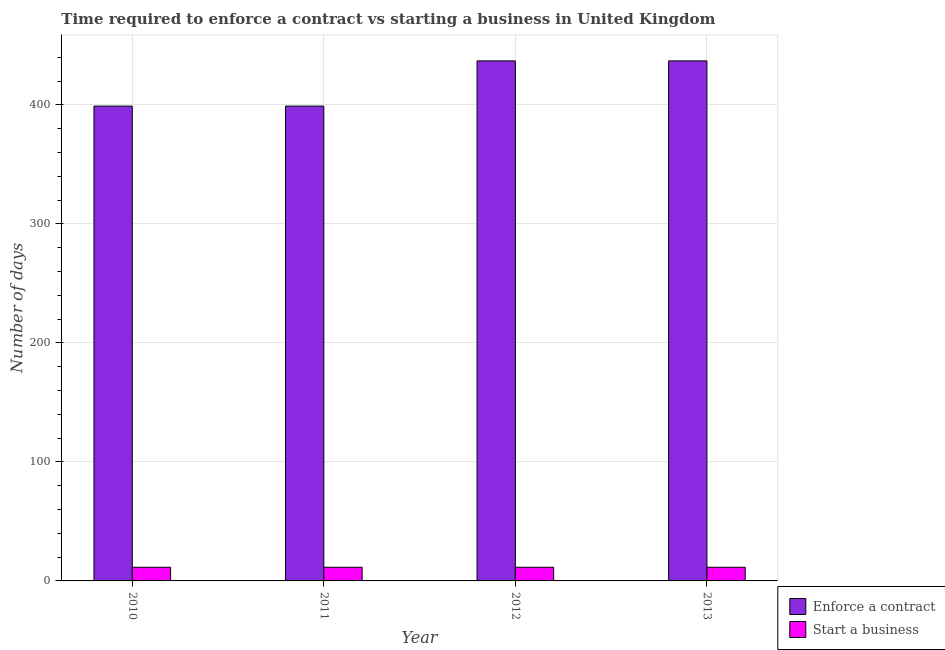Are the number of bars per tick equal to the number of legend labels?
Provide a succinct answer. Yes. How many bars are there on the 1st tick from the left?
Offer a terse response. 2. How many bars are there on the 2nd tick from the right?
Offer a very short reply. 2. What is the label of the 4th group of bars from the left?
Offer a very short reply. 2013. In how many cases, is the number of bars for a given year not equal to the number of legend labels?
Your response must be concise. 0. Across all years, what is the maximum number of days to enforece a contract?
Offer a very short reply. 437. Across all years, what is the minimum number of days to enforece a contract?
Give a very brief answer. 399. In which year was the number of days to start a business maximum?
Your answer should be very brief. 2010. In which year was the number of days to start a business minimum?
Offer a terse response. 2010. What is the total number of days to enforece a contract in the graph?
Provide a short and direct response. 1672. In the year 2013, what is the difference between the number of days to start a business and number of days to enforece a contract?
Your response must be concise. 0. Is the number of days to enforece a contract in 2011 less than that in 2013?
Your answer should be very brief. Yes. Is the difference between the number of days to enforece a contract in 2011 and 2012 greater than the difference between the number of days to start a business in 2011 and 2012?
Provide a short and direct response. No. What is the difference between the highest and the second highest number of days to enforece a contract?
Give a very brief answer. 0. In how many years, is the number of days to start a business greater than the average number of days to start a business taken over all years?
Provide a short and direct response. 0. What does the 2nd bar from the left in 2012 represents?
Offer a very short reply. Start a business. What does the 2nd bar from the right in 2010 represents?
Your answer should be very brief. Enforce a contract. How many bars are there?
Offer a very short reply. 8. Are all the bars in the graph horizontal?
Provide a succinct answer. No. How many years are there in the graph?
Provide a succinct answer. 4. Are the values on the major ticks of Y-axis written in scientific E-notation?
Offer a terse response. No. Does the graph contain any zero values?
Your answer should be compact. No. Does the graph contain grids?
Provide a short and direct response. Yes. Where does the legend appear in the graph?
Keep it short and to the point. Bottom right. How many legend labels are there?
Ensure brevity in your answer.  2. How are the legend labels stacked?
Make the answer very short. Vertical. What is the title of the graph?
Your answer should be very brief. Time required to enforce a contract vs starting a business in United Kingdom. What is the label or title of the X-axis?
Your response must be concise. Year. What is the label or title of the Y-axis?
Your answer should be compact. Number of days. What is the Number of days in Enforce a contract in 2010?
Give a very brief answer. 399. What is the Number of days in Start a business in 2010?
Offer a terse response. 11.5. What is the Number of days in Enforce a contract in 2011?
Keep it short and to the point. 399. What is the Number of days of Enforce a contract in 2012?
Give a very brief answer. 437. What is the Number of days in Enforce a contract in 2013?
Offer a terse response. 437. What is the Number of days in Start a business in 2013?
Keep it short and to the point. 11.5. Across all years, what is the maximum Number of days of Enforce a contract?
Offer a very short reply. 437. Across all years, what is the maximum Number of days of Start a business?
Your answer should be very brief. 11.5. Across all years, what is the minimum Number of days in Enforce a contract?
Give a very brief answer. 399. Across all years, what is the minimum Number of days of Start a business?
Your response must be concise. 11.5. What is the total Number of days of Enforce a contract in the graph?
Offer a terse response. 1672. What is the difference between the Number of days of Enforce a contract in 2010 and that in 2011?
Your answer should be compact. 0. What is the difference between the Number of days of Enforce a contract in 2010 and that in 2012?
Provide a succinct answer. -38. What is the difference between the Number of days of Start a business in 2010 and that in 2012?
Your answer should be very brief. 0. What is the difference between the Number of days in Enforce a contract in 2010 and that in 2013?
Your answer should be compact. -38. What is the difference between the Number of days in Start a business in 2010 and that in 2013?
Provide a short and direct response. 0. What is the difference between the Number of days in Enforce a contract in 2011 and that in 2012?
Your answer should be compact. -38. What is the difference between the Number of days of Start a business in 2011 and that in 2012?
Offer a very short reply. 0. What is the difference between the Number of days of Enforce a contract in 2011 and that in 2013?
Your answer should be very brief. -38. What is the difference between the Number of days of Start a business in 2011 and that in 2013?
Provide a short and direct response. 0. What is the difference between the Number of days of Enforce a contract in 2012 and that in 2013?
Provide a succinct answer. 0. What is the difference between the Number of days in Start a business in 2012 and that in 2013?
Keep it short and to the point. 0. What is the difference between the Number of days in Enforce a contract in 2010 and the Number of days in Start a business in 2011?
Keep it short and to the point. 387.5. What is the difference between the Number of days in Enforce a contract in 2010 and the Number of days in Start a business in 2012?
Keep it short and to the point. 387.5. What is the difference between the Number of days of Enforce a contract in 2010 and the Number of days of Start a business in 2013?
Make the answer very short. 387.5. What is the difference between the Number of days of Enforce a contract in 2011 and the Number of days of Start a business in 2012?
Your response must be concise. 387.5. What is the difference between the Number of days in Enforce a contract in 2011 and the Number of days in Start a business in 2013?
Keep it short and to the point. 387.5. What is the difference between the Number of days of Enforce a contract in 2012 and the Number of days of Start a business in 2013?
Give a very brief answer. 425.5. What is the average Number of days of Enforce a contract per year?
Make the answer very short. 418. In the year 2010, what is the difference between the Number of days of Enforce a contract and Number of days of Start a business?
Offer a very short reply. 387.5. In the year 2011, what is the difference between the Number of days of Enforce a contract and Number of days of Start a business?
Ensure brevity in your answer.  387.5. In the year 2012, what is the difference between the Number of days of Enforce a contract and Number of days of Start a business?
Keep it short and to the point. 425.5. In the year 2013, what is the difference between the Number of days in Enforce a contract and Number of days in Start a business?
Offer a very short reply. 425.5. What is the ratio of the Number of days in Enforce a contract in 2010 to that in 2013?
Your answer should be compact. 0.91. What is the ratio of the Number of days of Enforce a contract in 2011 to that in 2012?
Your answer should be compact. 0.91. What is the ratio of the Number of days of Start a business in 2011 to that in 2012?
Offer a terse response. 1. What is the ratio of the Number of days in Enforce a contract in 2011 to that in 2013?
Provide a succinct answer. 0.91. What is the ratio of the Number of days in Start a business in 2012 to that in 2013?
Your answer should be very brief. 1. What is the difference between the highest and the second highest Number of days of Enforce a contract?
Make the answer very short. 0. What is the difference between the highest and the second highest Number of days in Start a business?
Provide a short and direct response. 0. What is the difference between the highest and the lowest Number of days in Enforce a contract?
Your answer should be compact. 38. 